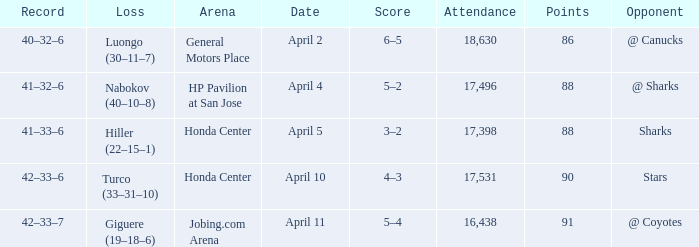Would you mind parsing the complete table? {'header': ['Record', 'Loss', 'Arena', 'Date', 'Score', 'Attendance', 'Points', 'Opponent'], 'rows': [['40–32–6', 'Luongo (30–11–7)', 'General Motors Place', 'April 2', '6–5', '18,630', '86', '@ Canucks'], ['41–32–6', 'Nabokov (40–10–8)', 'HP Pavilion at San Jose', 'April 4', '5–2', '17,496', '88', '@ Sharks'], ['41–33–6', 'Hiller (22–15–1)', 'Honda Center', 'April 5', '3–2', '17,398', '88', 'Sharks'], ['42–33–6', 'Turco (33–31–10)', 'Honda Center', 'April 10', '4–3', '17,531', '90', 'Stars'], ['42–33–7', 'Giguere (19–18–6)', 'Jobing.com Arena', 'April 11', '5–4', '16,438', '91', '@ Coyotes']]} On what date was the Record 41–32–6? April 4. 